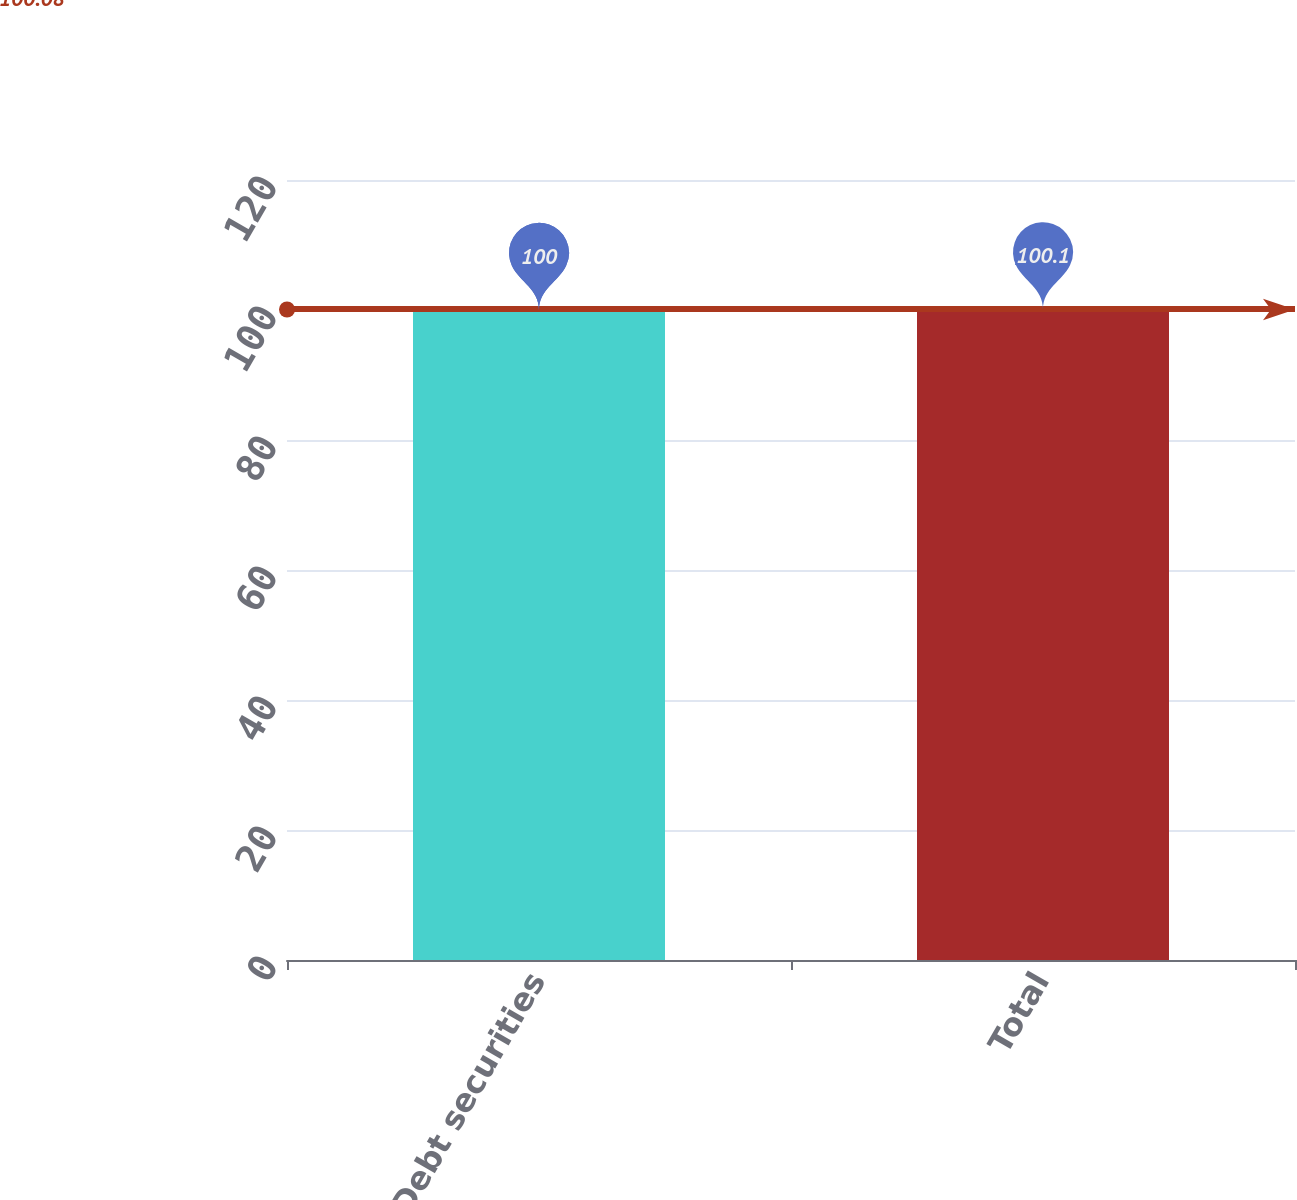<chart> <loc_0><loc_0><loc_500><loc_500><bar_chart><fcel>Debt securities<fcel>Total<nl><fcel>100<fcel>100.1<nl></chart> 